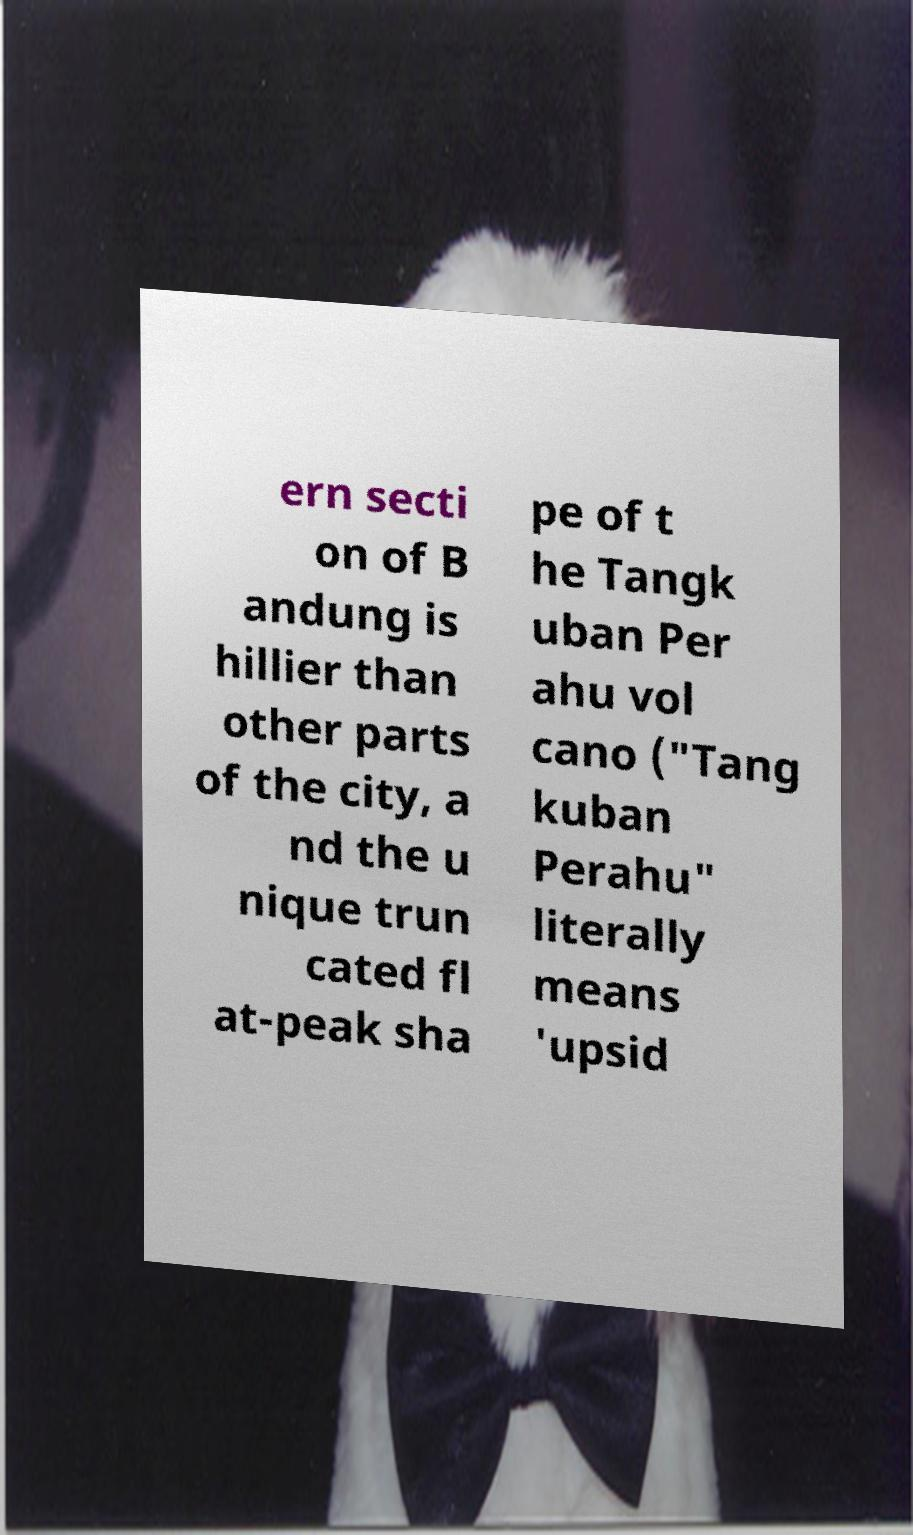Can you read and provide the text displayed in the image?This photo seems to have some interesting text. Can you extract and type it out for me? ern secti on of B andung is hillier than other parts of the city, a nd the u nique trun cated fl at-peak sha pe of t he Tangk uban Per ahu vol cano ("Tang kuban Perahu" literally means 'upsid 